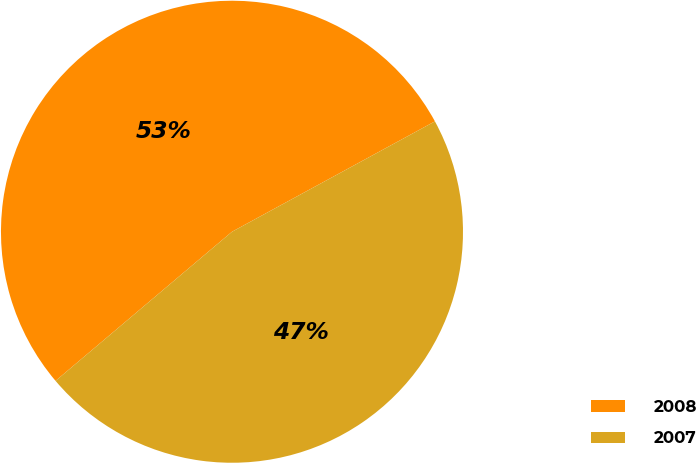Convert chart to OTSL. <chart><loc_0><loc_0><loc_500><loc_500><pie_chart><fcel>2008<fcel>2007<nl><fcel>53.24%<fcel>46.76%<nl></chart> 